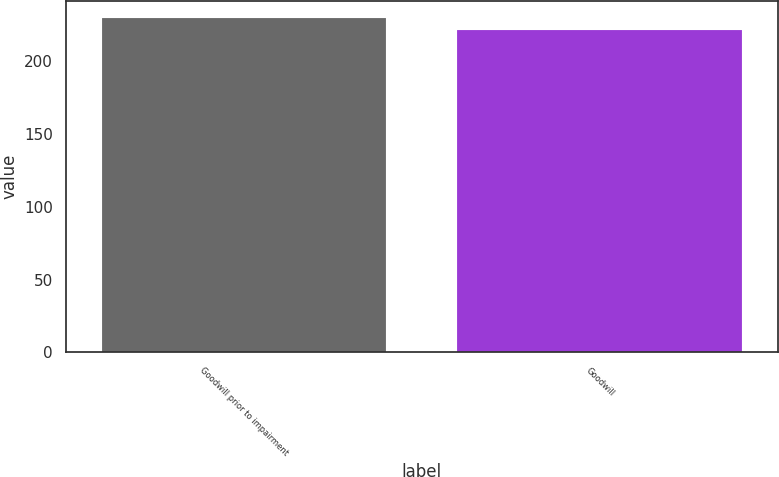Convert chart. <chart><loc_0><loc_0><loc_500><loc_500><bar_chart><fcel>Goodwill prior to impairment<fcel>Goodwill<nl><fcel>230.2<fcel>221.6<nl></chart> 